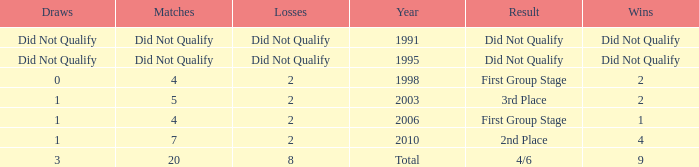What were the matches where the teams finished in the first group stage, in 1998? 4.0. 